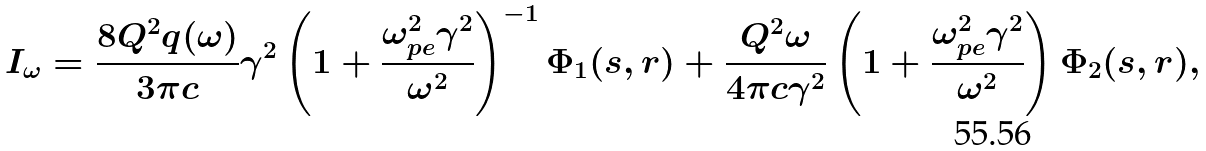Convert formula to latex. <formula><loc_0><loc_0><loc_500><loc_500>I _ { \omega } = \frac { 8 Q ^ { 2 } q ( \omega ) } { 3 \pi c } \gamma ^ { 2 } \left ( 1 + \frac { \omega _ { p e } ^ { 2 } \gamma ^ { 2 } } { \omega ^ { 2 } } \right ) ^ { - 1 } \Phi _ { 1 } ( s , r ) + \frac { Q ^ { 2 } \omega } { 4 \pi c \gamma ^ { 2 } } \left ( 1 + \frac { \omega _ { p e } ^ { 2 } \gamma ^ { 2 } } { \omega ^ { 2 } } \right ) \Phi _ { 2 } ( s , r ) ,</formula> 